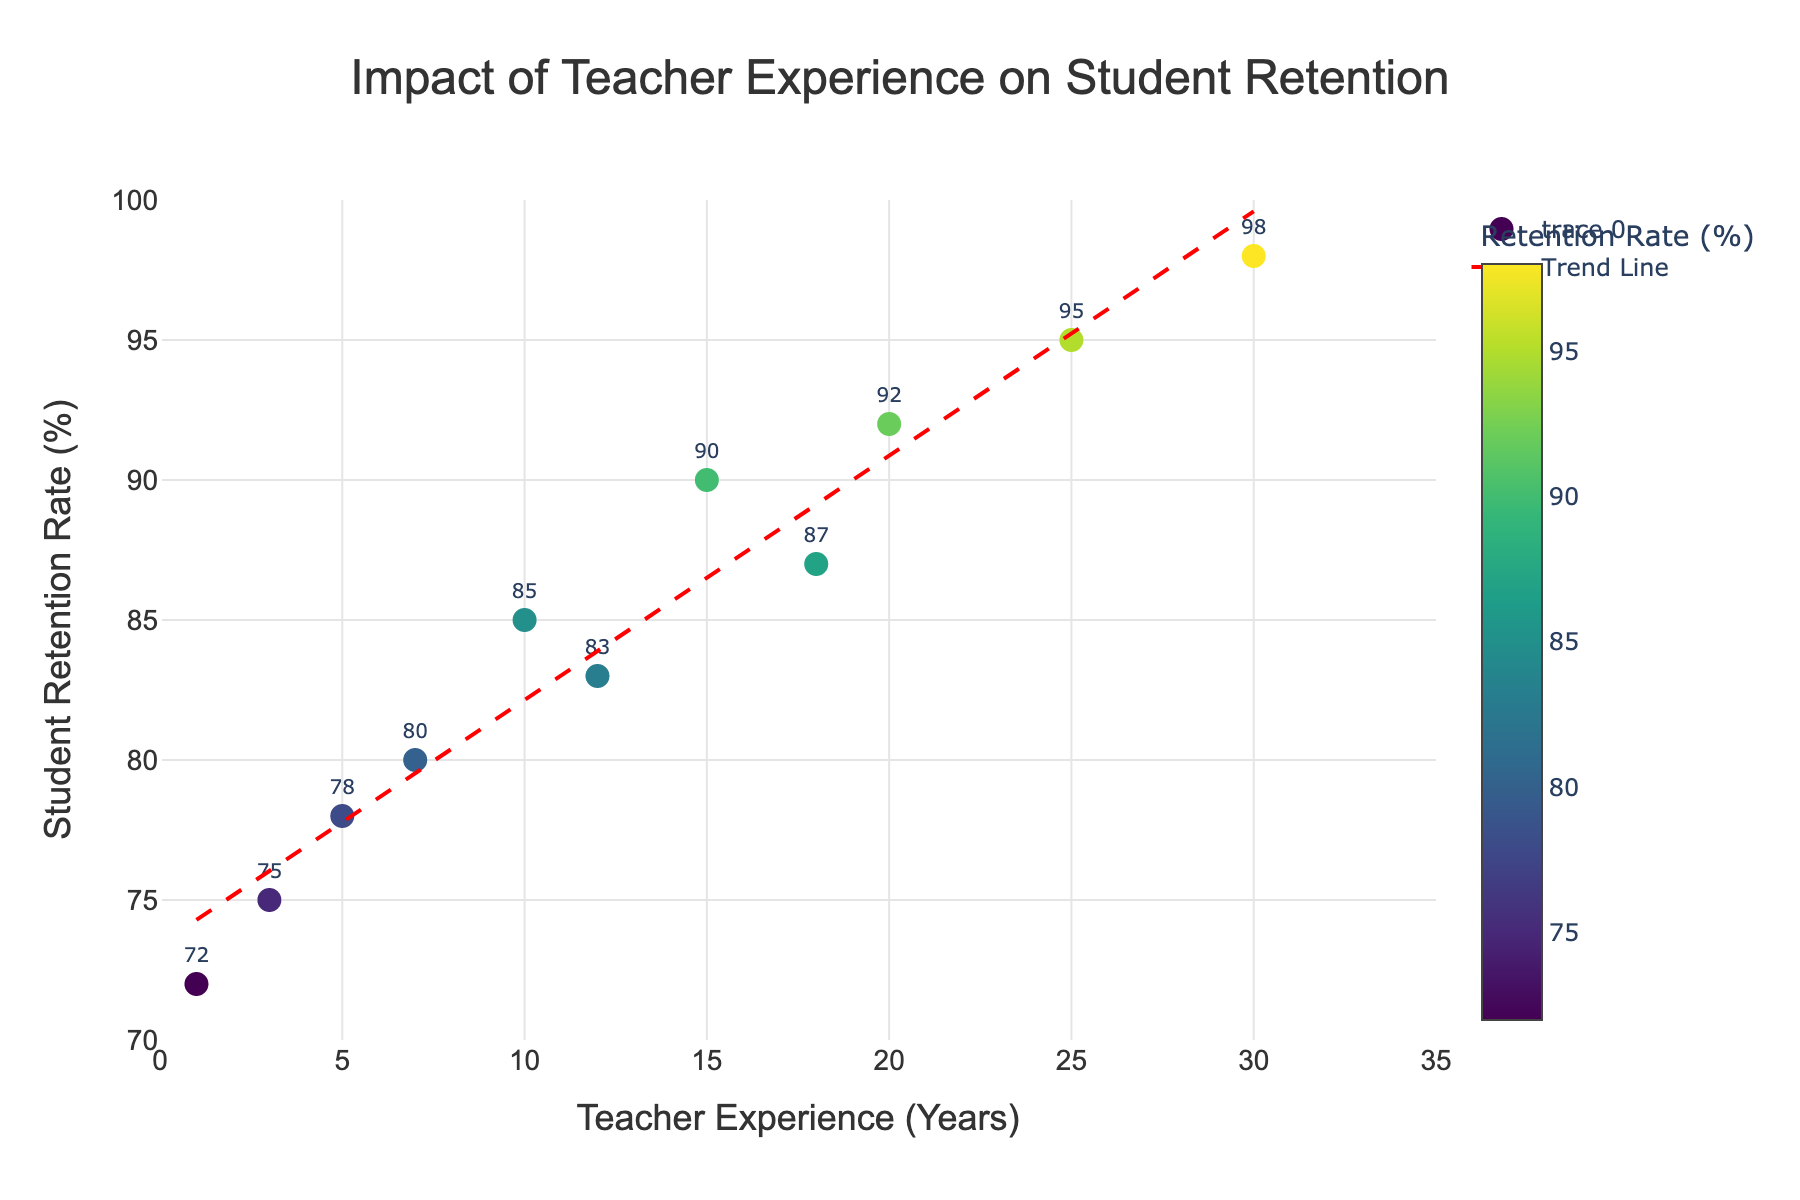What is the title of the figure? The title is prominently displayed at the top center of the figure and reads, "Impact of Teacher Experience on Student Retention".
Answer: Impact of Teacher Experience on Student Retention How many data points are there on the scatter plot? By counting the markers on the scatter plot, we see a total of 11 data points.
Answer: 11 What is the range of Teacher Experience (Years) on the x-axis? The x-axis spans from 0 to 35 years, as indicated in the axis settings.
Answer: 0 to 35 years What is the y-axis range for Student Retention Rate (%)? The y-axis is scaled from 70% to 100%, as shown on the figure.
Answer: 70% to 100% Which data point has the highest Student Retention Rate (%) and what is the corresponding Teacher Experience (Years)? The marker at 30 years of teacher experience has the highest retention rate of 98%, as indicated by the position of the marker within the plot.
Answer: 30 years, 98% What color trend is used to represent Student Retention Rate (%) on the scatter plot? The markers use a Viridis colorscale, which ranges from dark to bright colors with the brighter colors indicating higher retention rates.
Answer: Viridis colorscale What does the trend line in the scatter plot indicate about the relationship between Teacher Experience (Years) and Student Retention Rate (%)? The trend line is upward sloping, indicating a positive correlation between Teacher Experience and Student Retention Rate, suggesting that as teacher experience increases, retention rates generally increase too.
Answer: Positive correlation Which data point shows the lowest Student Retention Rate (%) and what is its corresponding Teacher Experience (Years)? The marker at 1 year of teacher experience has the lowest retention rate of 72%, as seen by its position and value on the plot.
Answer: 1 year, 72% Compare the Student Retention Rate (%) for teachers with 10 years of experience and those with 25 years of experience. By examining the markers, we see that teachers with 10 years of experience have a retention rate of 85%, while those with 25 years of experience have a rate of 95%, indicating a 10 percentage point increase.
Answer: 10 years: 85%, 25 years: 95% What is the average Student Retention Rate (%) for teachers with 5, 10, 15, and 20 years of experience? The retention rates for these years are 78%, 85%, 90%, and 92%, respectively. Summing these values gives 345%, and dividing by 4 gives an average of 86.25%.
Answer: 86.25% 